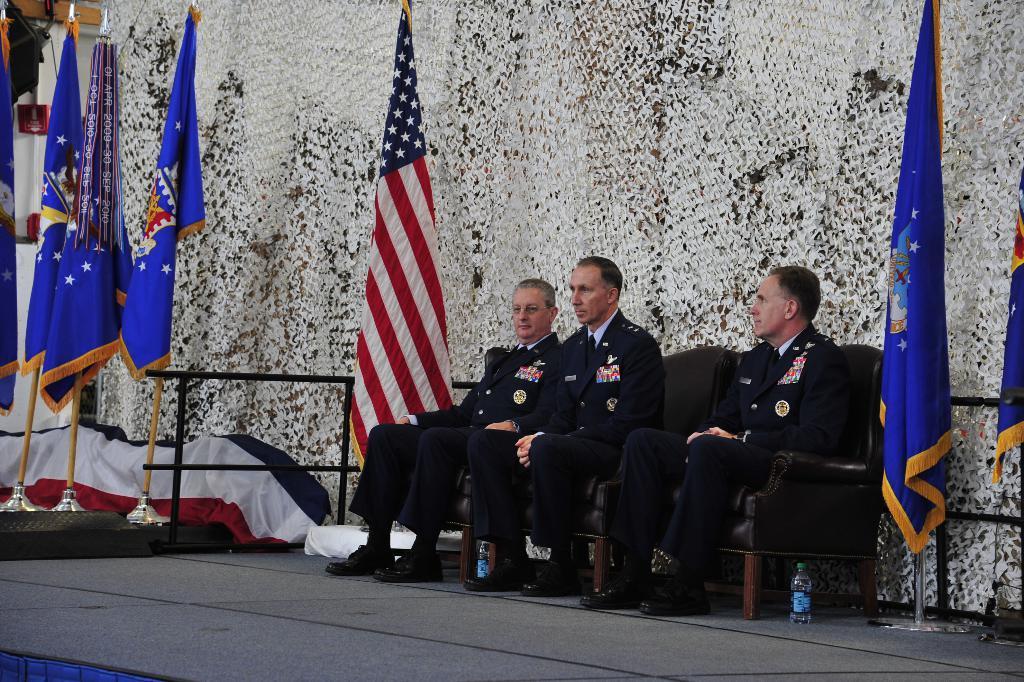Describe this image in one or two sentences. In this image we can see group of persons are sitting on the chairs, they are wearing the suit, beside there are flags, the background is in white color. 